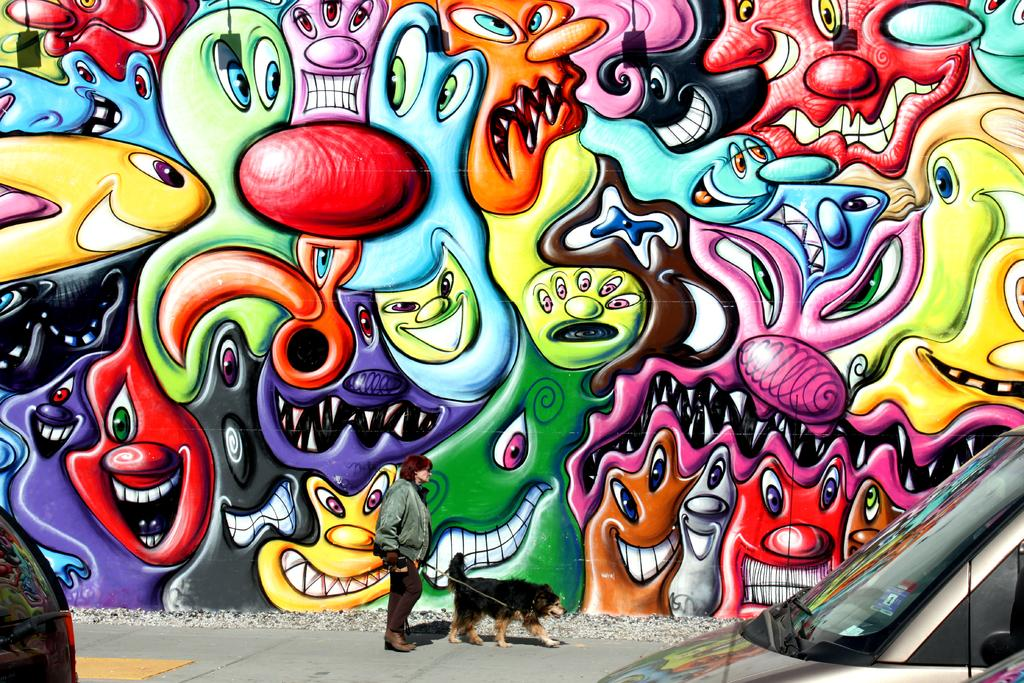What is the main subject of the image? There is a person in the image. What type of animal can be seen with the person? There is a black-colored dog in the image. What else is present in the image besides the person and the dog? There are vehicles and graffiti on a wall in the image. What is the person wearing in the image? The person in the image is wearing a jacket. What type of gold ant can be seen on the person's shoulder in the image? There is no gold ant present on the person's shoulder in the image. 